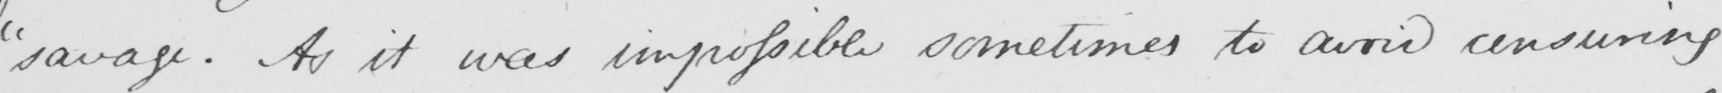Please transcribe the handwritten text in this image. " savage . As it was impossible sometimes to avoid censuring 